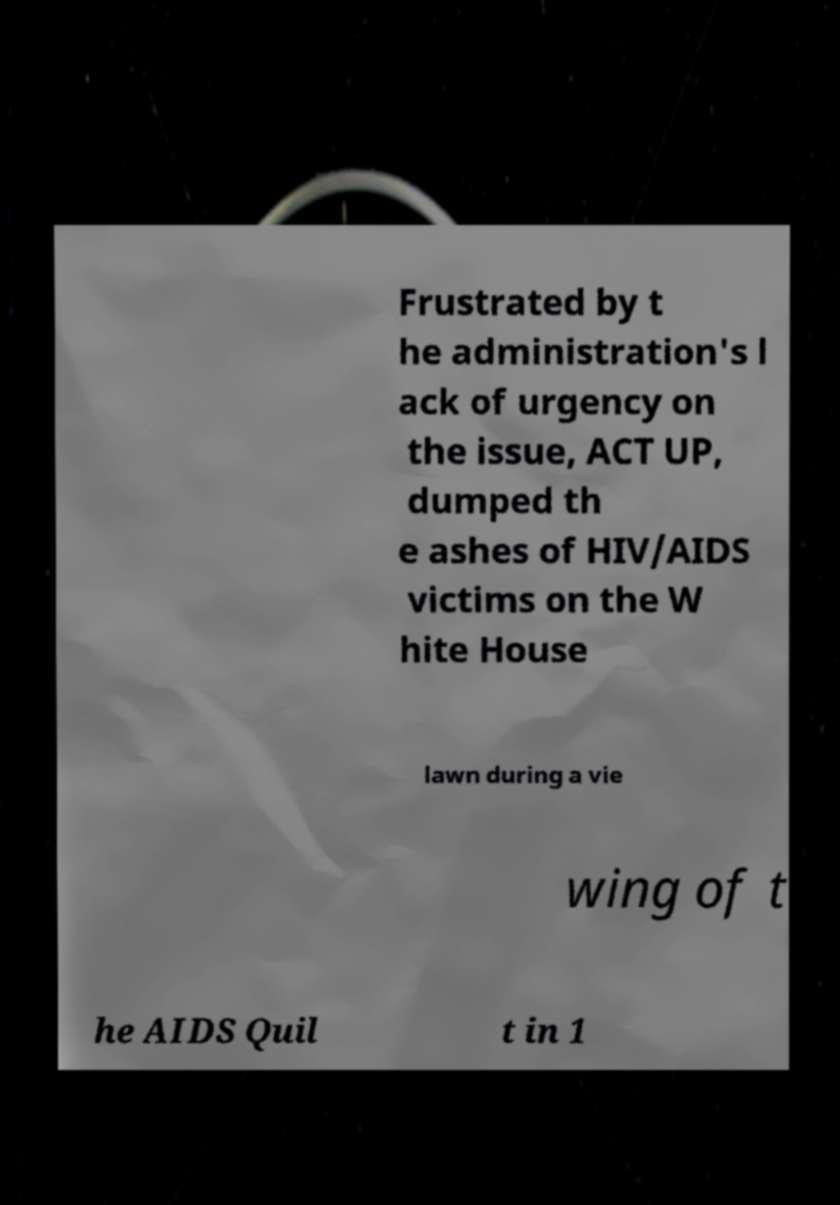There's text embedded in this image that I need extracted. Can you transcribe it verbatim? Frustrated by t he administration's l ack of urgency on the issue, ACT UP, dumped th e ashes of HIV/AIDS victims on the W hite House lawn during a vie wing of t he AIDS Quil t in 1 